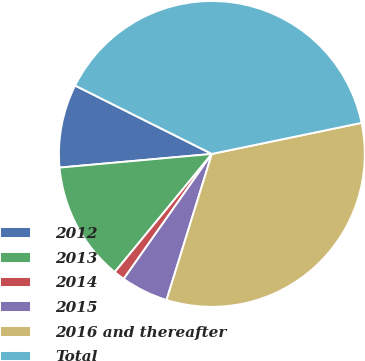<chart> <loc_0><loc_0><loc_500><loc_500><pie_chart><fcel>2012<fcel>2013<fcel>2014<fcel>2015<fcel>2016 and thereafter<fcel>Total<nl><fcel>8.81%<fcel>12.63%<fcel>1.17%<fcel>4.99%<fcel>33.05%<fcel>39.37%<nl></chart> 